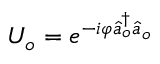Convert formula to latex. <formula><loc_0><loc_0><loc_500><loc_500>U _ { o } = e ^ { - i \varphi \hat { a } _ { o } ^ { \dagger } \hat { a } _ { o } }</formula> 